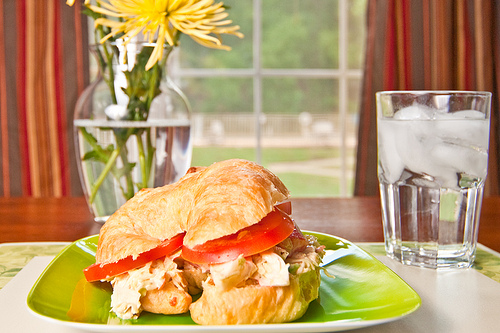Are there croissants or pancakes that are not gold? No, there are no croissants or pancakes that are not gold-colored in the image. 